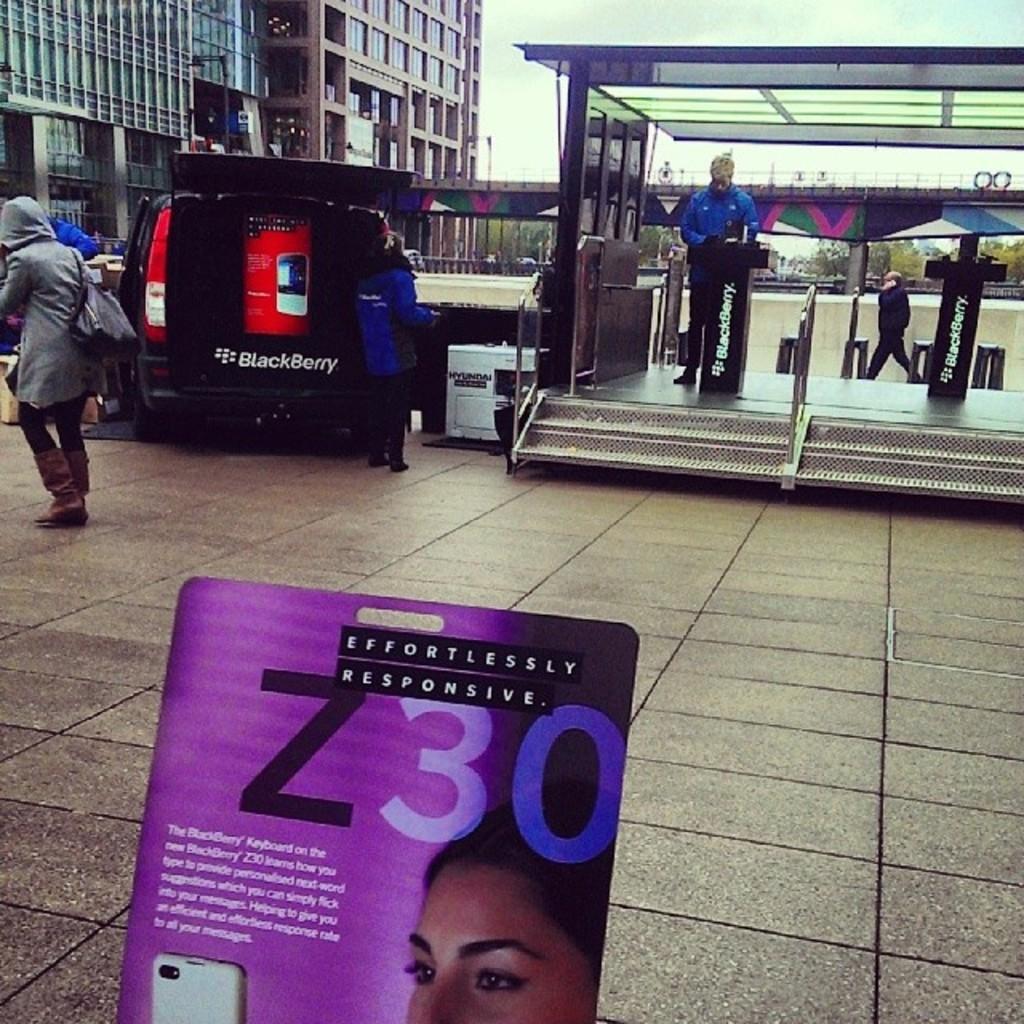How would you summarize this image in a sentence or two? In the picture we can see a path with tiles on it we can see a shop with a desk in it and a brand name blackberry on it and a person standing near it and beside the shop we can see a car and beside it we can see a person walking wearing a hand bag and in the background we can see a building with glasses and near it we can see a bridge with a railing and behind it we can see some poles and sky. 